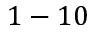Convert formula to latex. <formula><loc_0><loc_0><loc_500><loc_500>1 - 1 0</formula> 